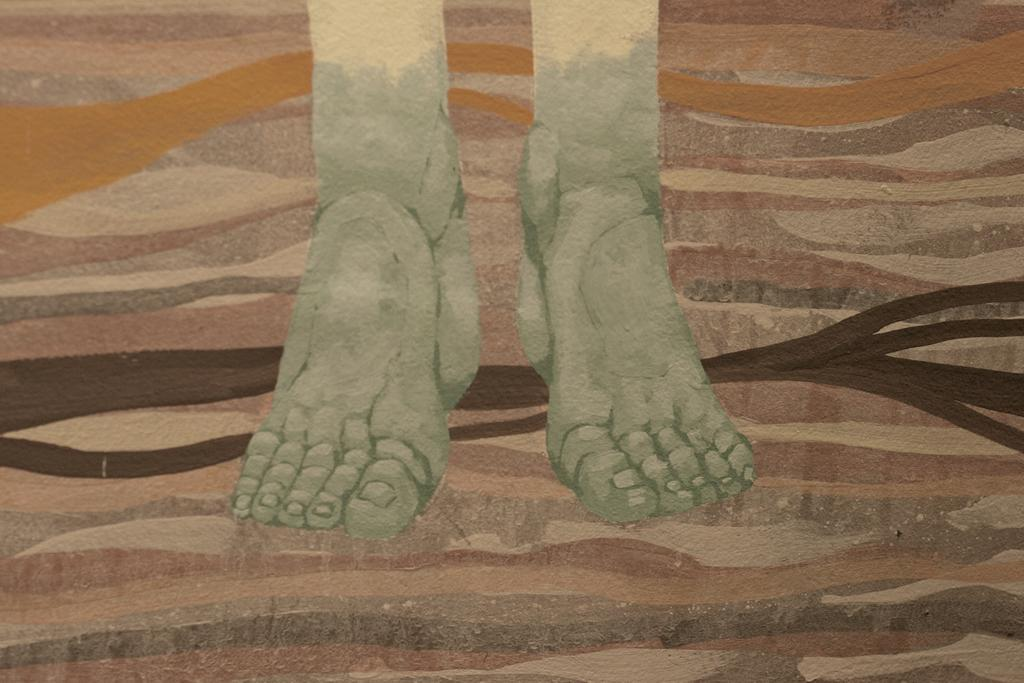What is the main subject of the image? The main subject of the image is a painting. What can be seen in the painting? The painting contains the legs of a person. How many frogs are jumping in the river depicted in the painting? There is no river or frogs depicted in the painting; it only contains the legs of a person. 